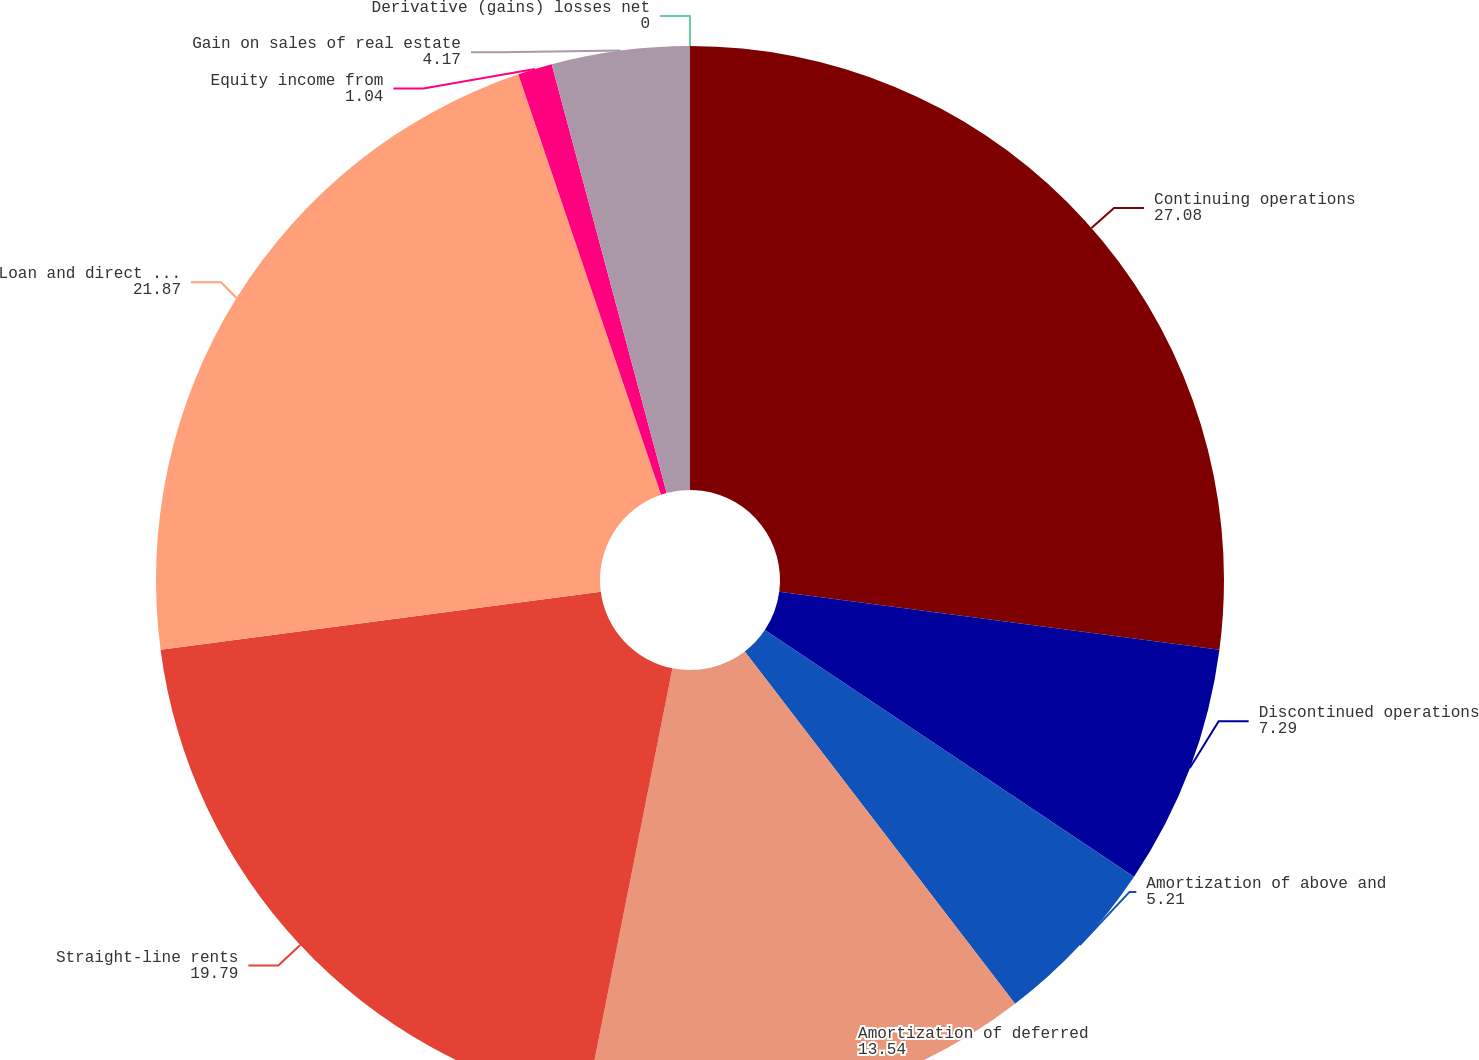<chart> <loc_0><loc_0><loc_500><loc_500><pie_chart><fcel>Continuing operations<fcel>Discontinued operations<fcel>Amortization of above and<fcel>Amortization of deferred<fcel>Straight-line rents<fcel>Loan and direct financing<fcel>Equity income from<fcel>Gain on sales of real estate<fcel>Derivative (gains) losses net<nl><fcel>27.08%<fcel>7.29%<fcel>5.21%<fcel>13.54%<fcel>19.79%<fcel>21.87%<fcel>1.04%<fcel>4.17%<fcel>0.0%<nl></chart> 